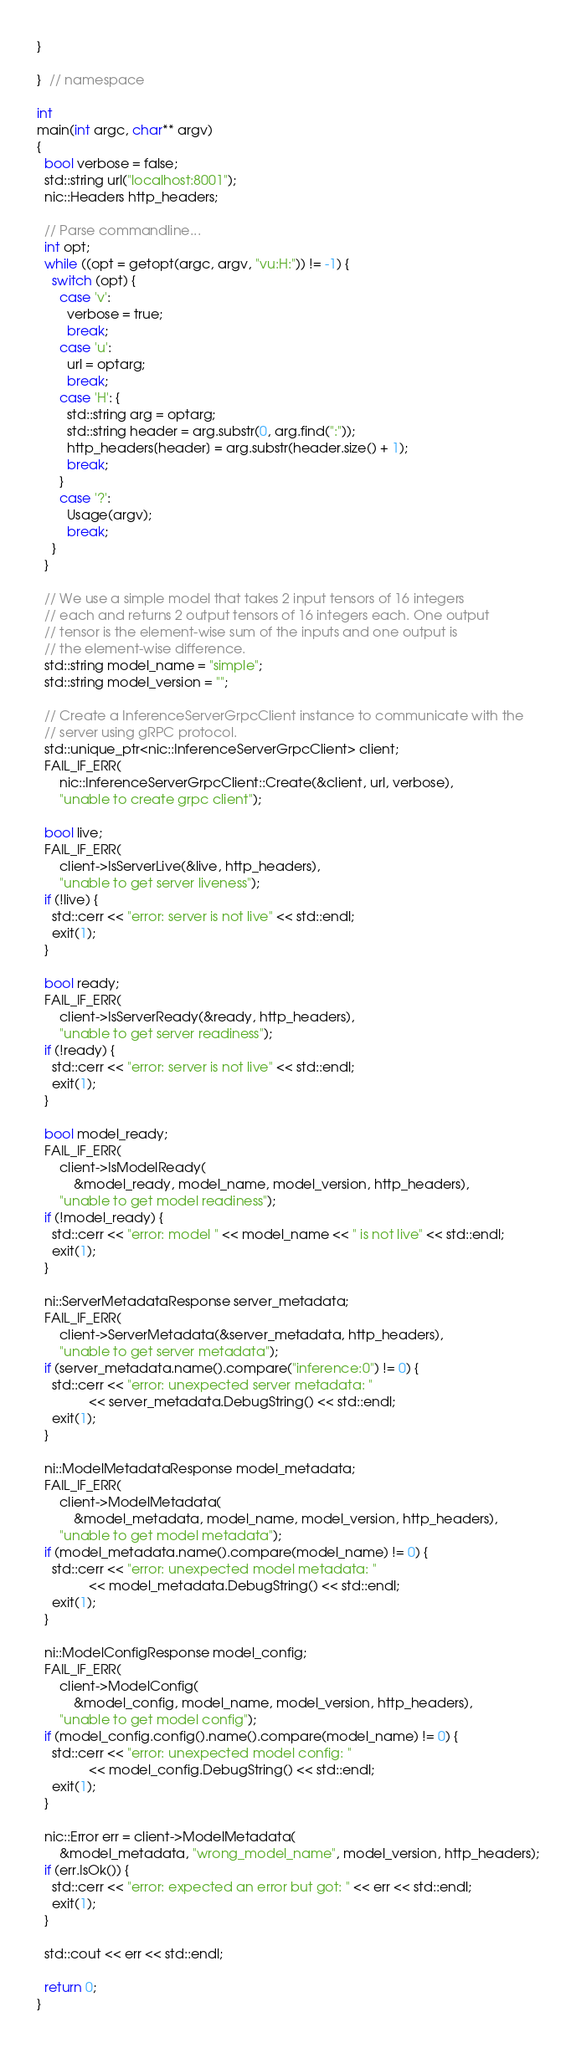<code> <loc_0><loc_0><loc_500><loc_500><_C++_>}

}  // namespace

int
main(int argc, char** argv)
{
  bool verbose = false;
  std::string url("localhost:8001");
  nic::Headers http_headers;

  // Parse commandline...
  int opt;
  while ((opt = getopt(argc, argv, "vu:H:")) != -1) {
    switch (opt) {
      case 'v':
        verbose = true;
        break;
      case 'u':
        url = optarg;
        break;
      case 'H': {
        std::string arg = optarg;
        std::string header = arg.substr(0, arg.find(":"));
        http_headers[header] = arg.substr(header.size() + 1);
        break;
      }
      case '?':
        Usage(argv);
        break;
    }
  }

  // We use a simple model that takes 2 input tensors of 16 integers
  // each and returns 2 output tensors of 16 integers each. One output
  // tensor is the element-wise sum of the inputs and one output is
  // the element-wise difference.
  std::string model_name = "simple";
  std::string model_version = "";

  // Create a InferenceServerGrpcClient instance to communicate with the
  // server using gRPC protocol.
  std::unique_ptr<nic::InferenceServerGrpcClient> client;
  FAIL_IF_ERR(
      nic::InferenceServerGrpcClient::Create(&client, url, verbose),
      "unable to create grpc client");

  bool live;
  FAIL_IF_ERR(
      client->IsServerLive(&live, http_headers),
      "unable to get server liveness");
  if (!live) {
    std::cerr << "error: server is not live" << std::endl;
    exit(1);
  }

  bool ready;
  FAIL_IF_ERR(
      client->IsServerReady(&ready, http_headers),
      "unable to get server readiness");
  if (!ready) {
    std::cerr << "error: server is not live" << std::endl;
    exit(1);
  }

  bool model_ready;
  FAIL_IF_ERR(
      client->IsModelReady(
          &model_ready, model_name, model_version, http_headers),
      "unable to get model readiness");
  if (!model_ready) {
    std::cerr << "error: model " << model_name << " is not live" << std::endl;
    exit(1);
  }

  ni::ServerMetadataResponse server_metadata;
  FAIL_IF_ERR(
      client->ServerMetadata(&server_metadata, http_headers),
      "unable to get server metadata");
  if (server_metadata.name().compare("inference:0") != 0) {
    std::cerr << "error: unexpected server metadata: "
              << server_metadata.DebugString() << std::endl;
    exit(1);
  }

  ni::ModelMetadataResponse model_metadata;
  FAIL_IF_ERR(
      client->ModelMetadata(
          &model_metadata, model_name, model_version, http_headers),
      "unable to get model metadata");
  if (model_metadata.name().compare(model_name) != 0) {
    std::cerr << "error: unexpected model metadata: "
              << model_metadata.DebugString() << std::endl;
    exit(1);
  }

  ni::ModelConfigResponse model_config;
  FAIL_IF_ERR(
      client->ModelConfig(
          &model_config, model_name, model_version, http_headers),
      "unable to get model config");
  if (model_config.config().name().compare(model_name) != 0) {
    std::cerr << "error: unexpected model config: "
              << model_config.DebugString() << std::endl;
    exit(1);
  }

  nic::Error err = client->ModelMetadata(
      &model_metadata, "wrong_model_name", model_version, http_headers);
  if (err.IsOk()) {
    std::cerr << "error: expected an error but got: " << err << std::endl;
    exit(1);
  }

  std::cout << err << std::endl;

  return 0;
}
</code> 